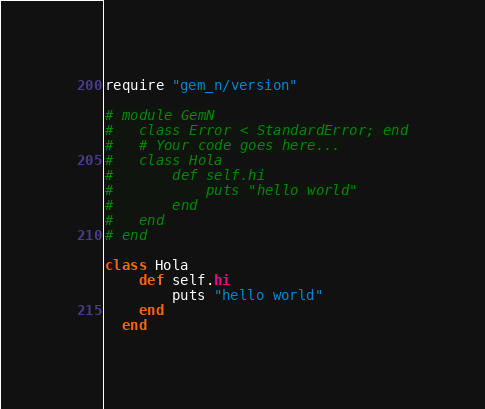<code> <loc_0><loc_0><loc_500><loc_500><_Ruby_>require "gem_n/version"

# module GemN
#   class Error < StandardError; end
#   # Your code goes here...
#   class Hola
#   	def self.hi
#   		puts "hello world"
#   	end
#   end
# end

class Hola
  	def self.hi
  		puts "hello world"
  	end
  end</code> 